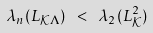Convert formula to latex. <formula><loc_0><loc_0><loc_500><loc_500>\lambda _ { n } ( { L } _ { \mathcal { K } \Lambda } ) \ < \ \lambda _ { 2 } ( { L } _ { \mathcal { K } } ^ { 2 } )</formula> 